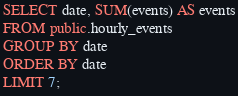Convert code to text. <code><loc_0><loc_0><loc_500><loc_500><_SQL_>SELECT date, SUM(events) AS events
FROM public.hourly_events
GROUP BY date
ORDER BY date
LIMIT 7;</code> 